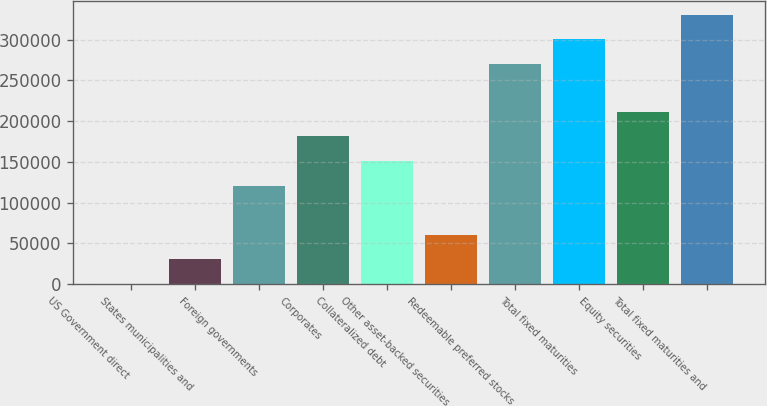Convert chart to OTSL. <chart><loc_0><loc_0><loc_500><loc_500><bar_chart><fcel>US Government direct<fcel>States municipalities and<fcel>Foreign governments<fcel>Corporates<fcel>Collateralized debt<fcel>Other asset-backed securities<fcel>Redeemable preferred stocks<fcel>Total fixed maturities<fcel>Equity securities<fcel>Total fixed maturities and<nl><fcel>0.21<fcel>30202.2<fcel>120808<fcel>181212<fcel>151010<fcel>60404.2<fcel>270189<fcel>300391<fcel>211414<fcel>330593<nl></chart> 